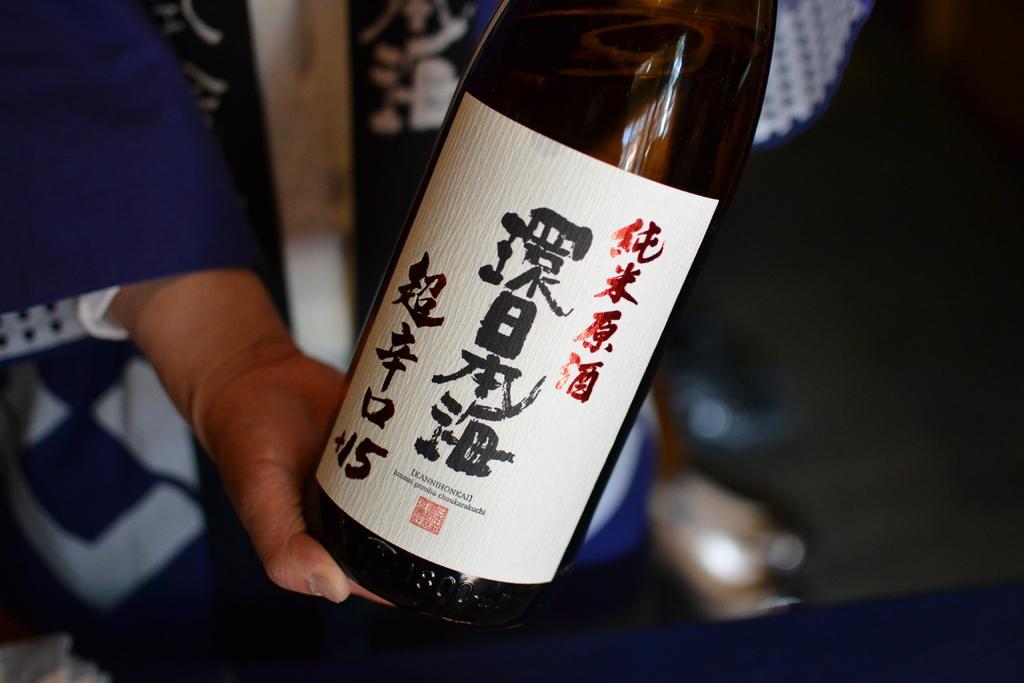In one or two sentences, can you explain what this image depicts? As we can see in the image, there is a person holding bottle in his hand. 